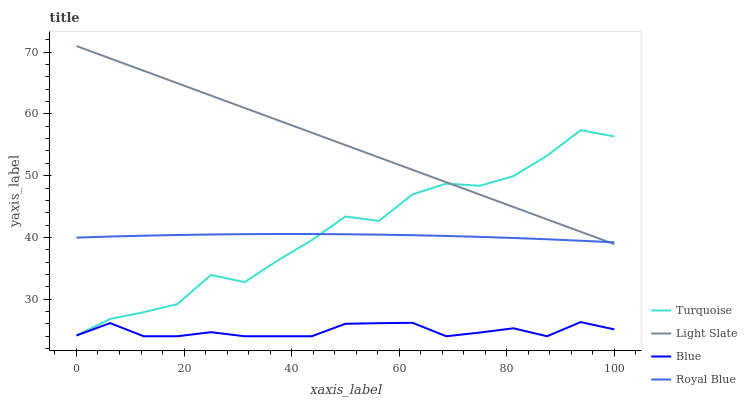Does Blue have the minimum area under the curve?
Answer yes or no. Yes. Does Turquoise have the minimum area under the curve?
Answer yes or no. No. Does Turquoise have the maximum area under the curve?
Answer yes or no. No. Is Turquoise the roughest?
Answer yes or no. Yes. Is Blue the smoothest?
Answer yes or no. No. Is Blue the roughest?
Answer yes or no. No. Does Turquoise have the lowest value?
Answer yes or no. No. Does Turquoise have the highest value?
Answer yes or no. No. Is Blue less than Royal Blue?
Answer yes or no. Yes. Is Royal Blue greater than Blue?
Answer yes or no. Yes. Does Blue intersect Royal Blue?
Answer yes or no. No. 